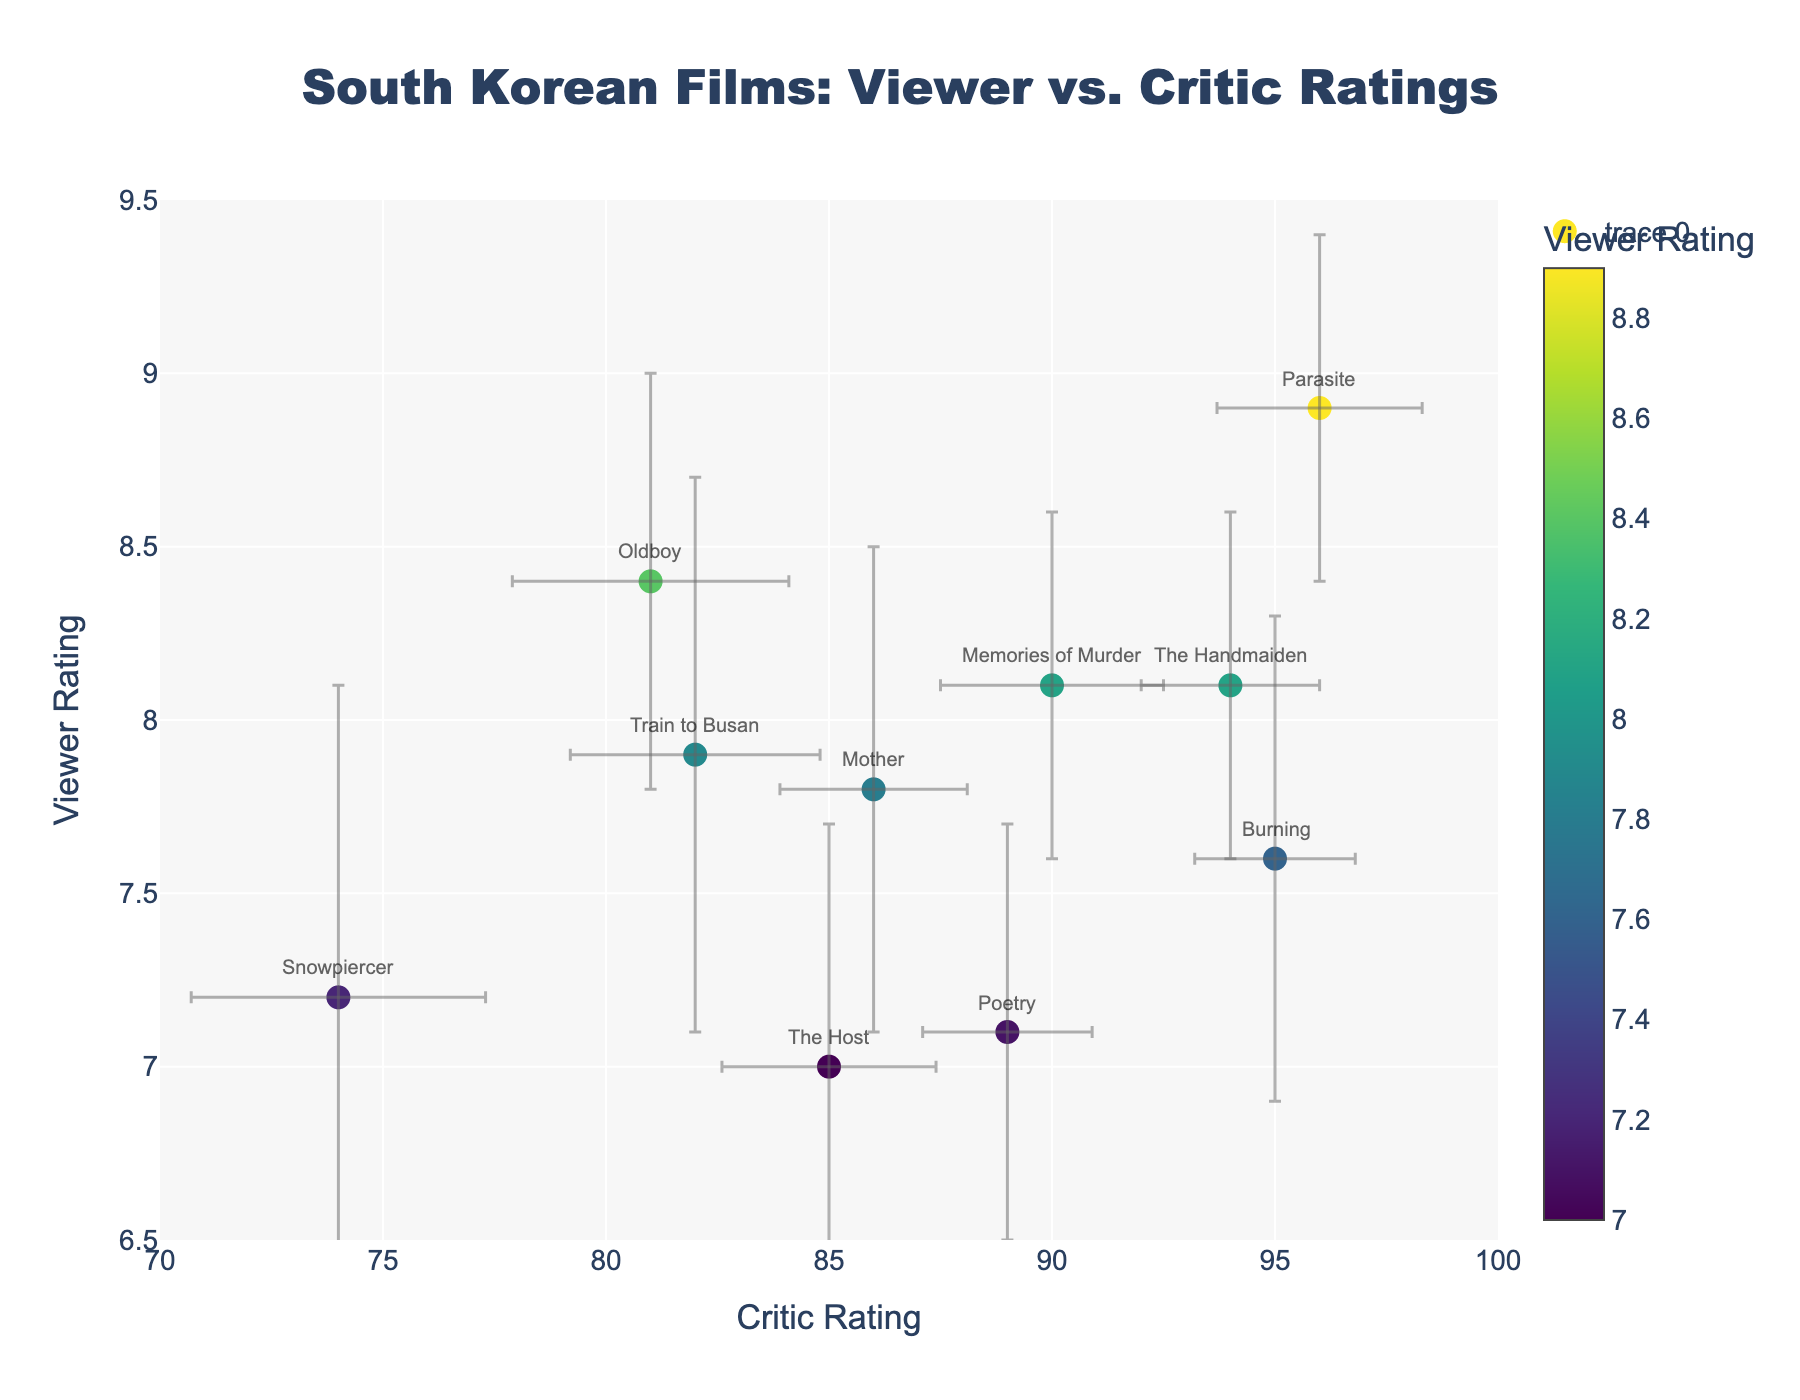what is the highest viewer rating in the plot? Look at the y-axis, find the highest data point on this axis. "Parasite" has the highest viewer rating at 8.9.
Answer: "Parasite" What is the range of critic ratings? Look at the x-axis, find the minimum and maximum data points. The critic ratings range from 74 ("Snowpiercer") to 96 ("Parasite").
Answer: 74 to 96 Which film has the smallest variability in critic ratings? Look at the error bars along the x-axis, smallest variability means the shortest error bar. "Burning" has the smallest error bar on the x-axis with a standard deviation of 1.8.
Answer: "Burning" Which film has the widest range of viewer ratings? Look at the error bars along the y-axis, widest range means the longest error bar. "Snowpiercer" has the longest error bar on the y-axis with a standard deviation of 0.9.
Answer: "Snowpiercer" Which film has the closest viewer rating to 8.0? Find the data point on the y-axis nearest to 8.0. "The Handmaiden" and "Memories of Murder" are closest with viewer ratings of 8.1.
Answer: "The Handmaiden" and "Memories of Murder" How many films have both viewer and critic ratings above their respective median values? Calculate the median for viewer and critic ratings. Median viewer rating = 7.75, median critic rating = 86. Identify films above these medians: "Parasite", "Burning", and "The Handmaiden".
Answer: 3 films Which film has the largest discrepancy between viewer and critic ratings? Calculate the differences between critic ratings and viewer ratings for each film. "Parasite" has the largest discrepancy since Critic Rating - Viewer Rating = 96 - 8.9 = 87.1.
Answer: "Parasite" Is there a film with a higher viewer rating but a lower critic rating compared to "Oldboy"? Compare viewer and critic ratings of all films to "Oldboy" (8.4, 81). "Train to Busan" has a higher viewer rating (7.9 vs 8.4) but a lower critic rating (82 vs 81).
Answer: No 